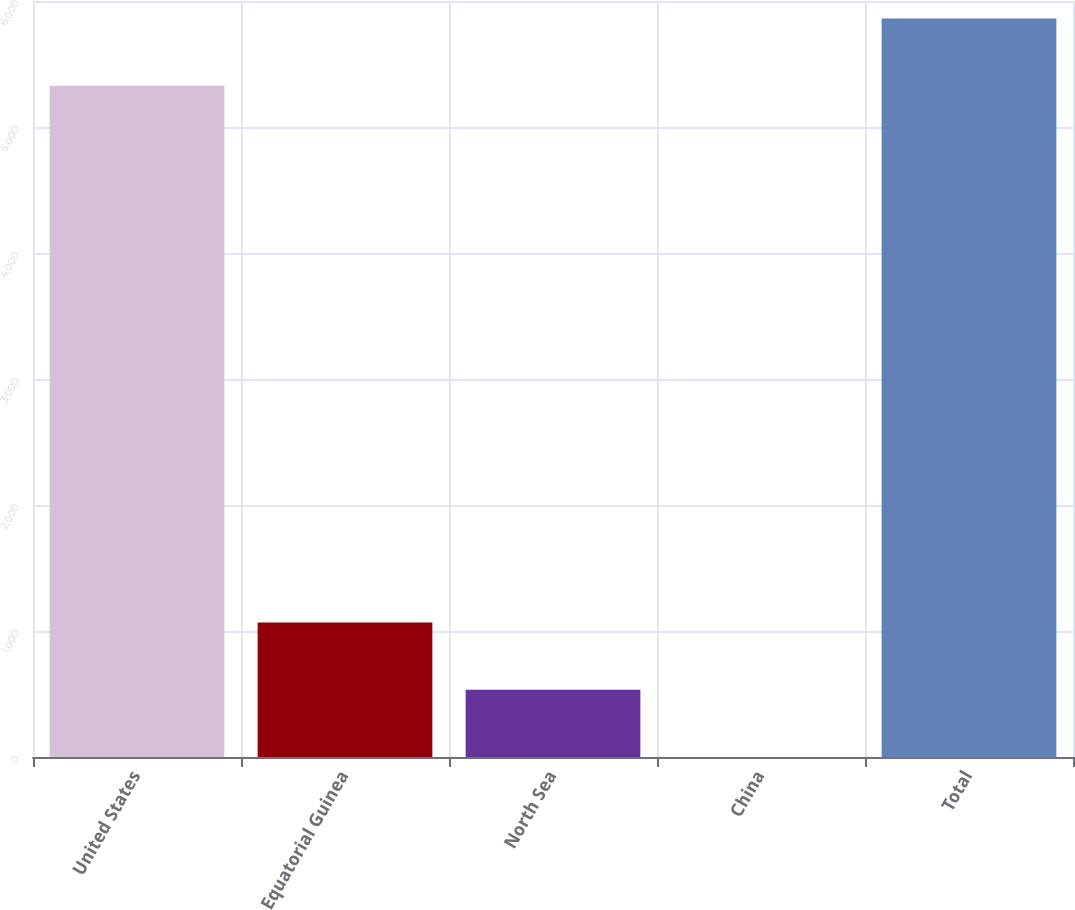<chart> <loc_0><loc_0><loc_500><loc_500><bar_chart><fcel>United States<fcel>Equatorial Guinea<fcel>North Sea<fcel>China<fcel>Total<nl><fcel>5327.7<fcel>1067.62<fcel>534.11<fcel>0.6<fcel>5861.21<nl></chart> 